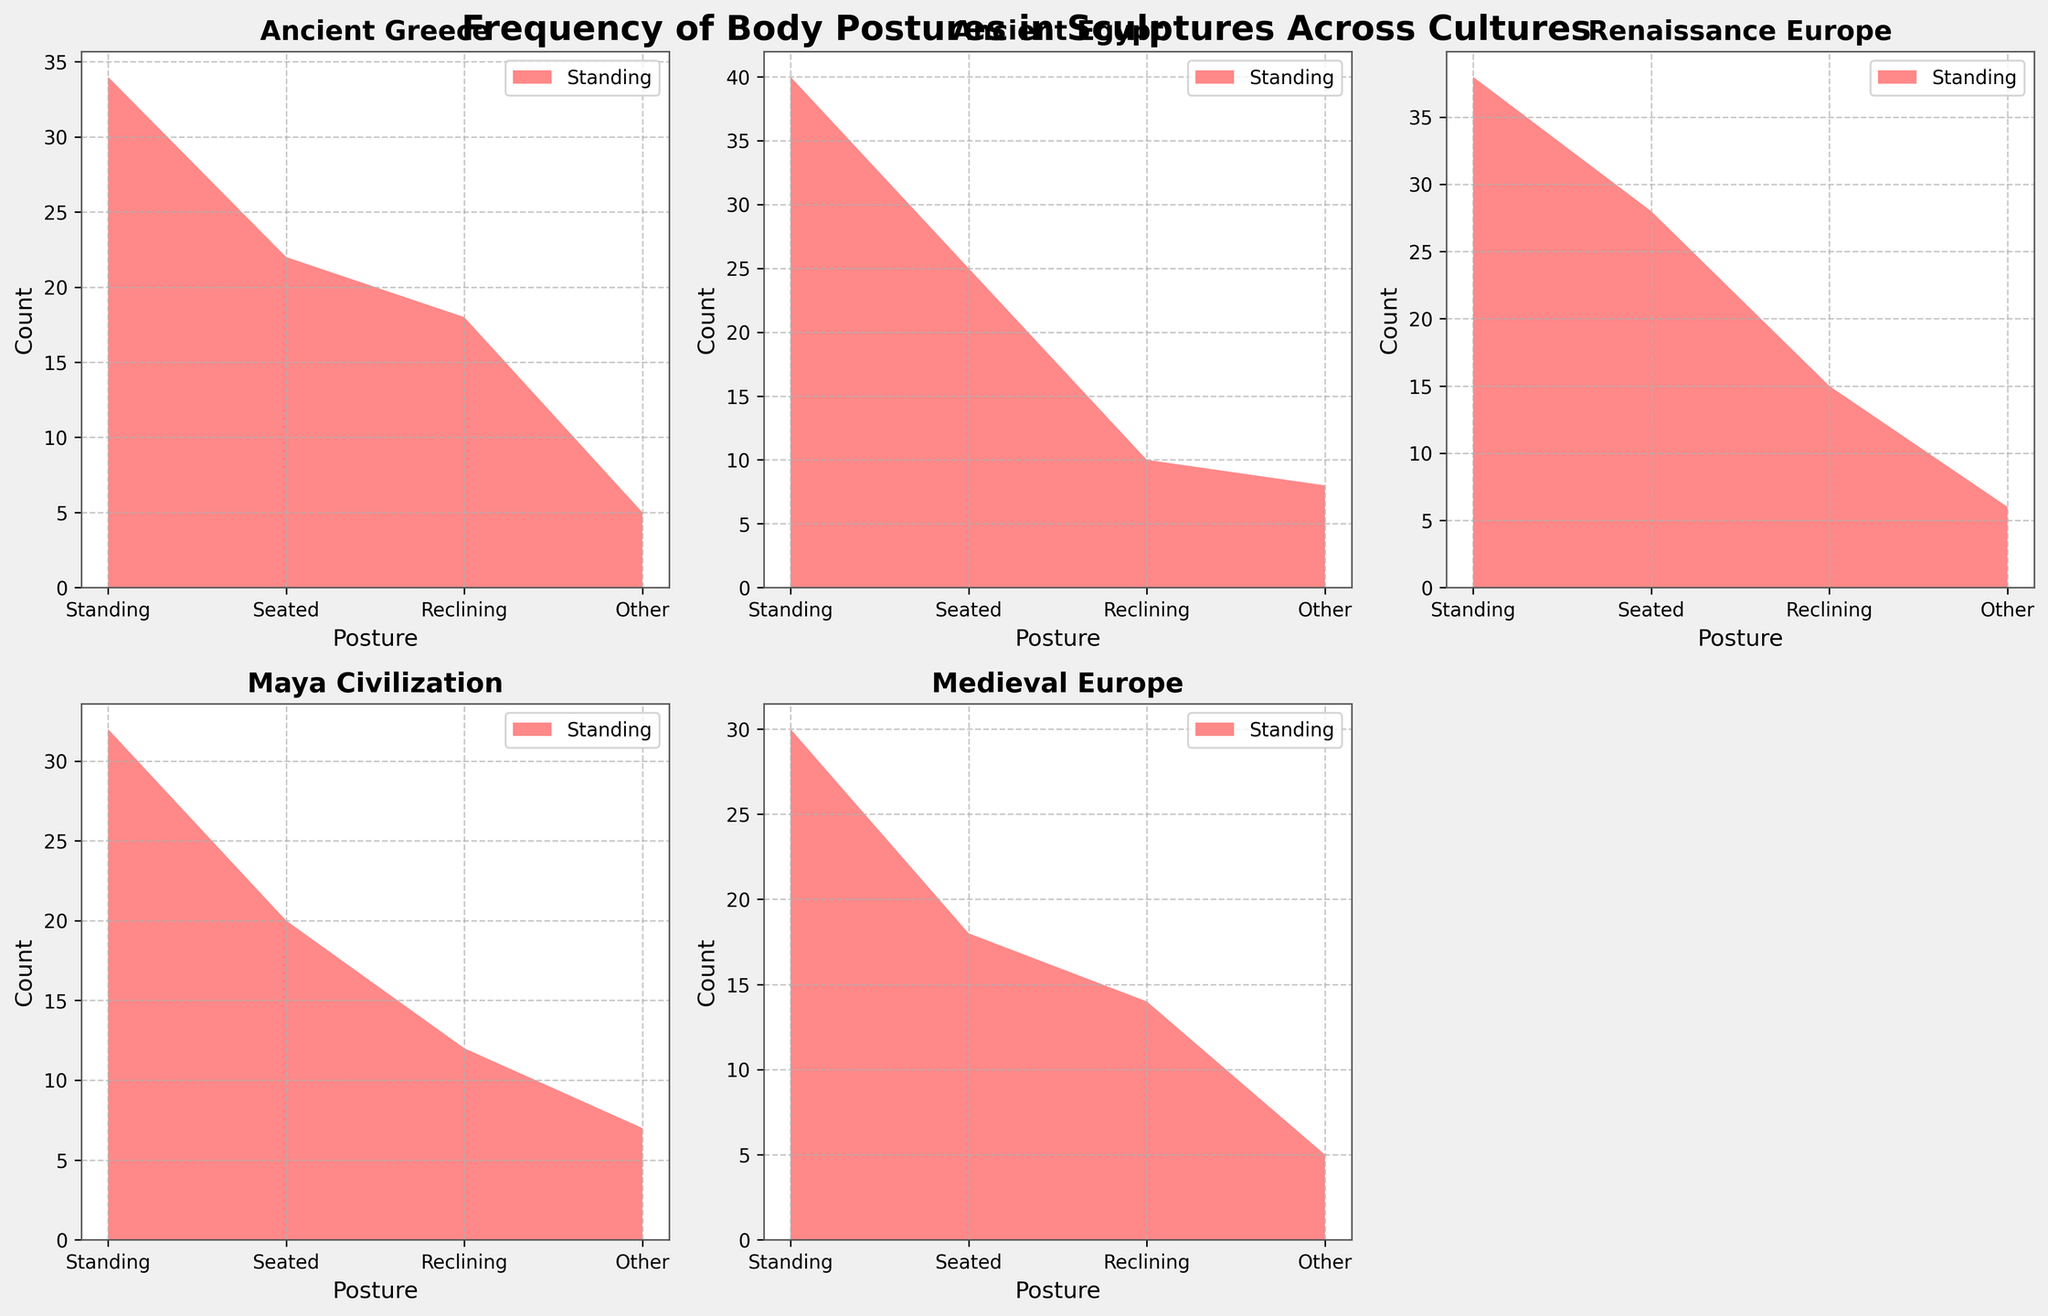What is the title of the figure? The title is usually displayed at the top of the figure and summarizes the overall content of the plot.
Answer: Frequency of Body Postures in Sculptures Across Cultures Which culture has the most sculptures depicting standing postures? To find this, locate the subplot for each culture and look at the section representing 'Standing' postures. The culture with the highest count will be the answer.
Answer: Ancient Egypt What posture is least depicted in the Maya Civilization according to the figure? Find the subplot for 'Maya Civilization' and identify which posture section has the smallest area.
Answer: Other How many cultures have reclining postures greater than 12? Check each subplot for the 'Reclining' posture and count how many cultures have values exceeding 12.
Answer: Three (Ancient Greece, Renaissance Europe, Medieval Europe) Which culture has the lowest variety (count of postures depicted) in different postures, as shown in the figure? Analyze each subplot and see which cultural subplot's areas are the smallest or have missing areas.
Answer: Ancient Greece Compare the counts of seated postures between Ancient Greece and the Renaissance Europe. Which one has more? Look at the 'Seated' sections of the subplots for both Ancient Greece and Renaissance Europe and compare their areas.
Answer: Renaissance Europe Which culture's stacked area shows the most uniform distribution across all postures? Examine each subplot to see which one has roughly equal areas for all postures.
Answer: Ancient Egypt What's the total count of sculptures depicted for Medieval Europe in all postures combined? Add up the counts for each posture in the 'Medieval Europe' subplot. It will be 30+18+14+5 = 67
Answer: 67 Between Ancient Egypt and Renaissance Europe, which culture has a greater count of 'Other' postures? Look at the 'Other' section on both the Ancient Egypt and Renaissance Europe subplots and compare their values.
Answer: Ancient Egypt Is the count of reclining postures in Ancient Egypt higher or lower than in Medieval Europe? Compare the area representing 'Reclining' postures in the subplots for Ancient Egypt and Medieval Europe.
Answer: Lower 